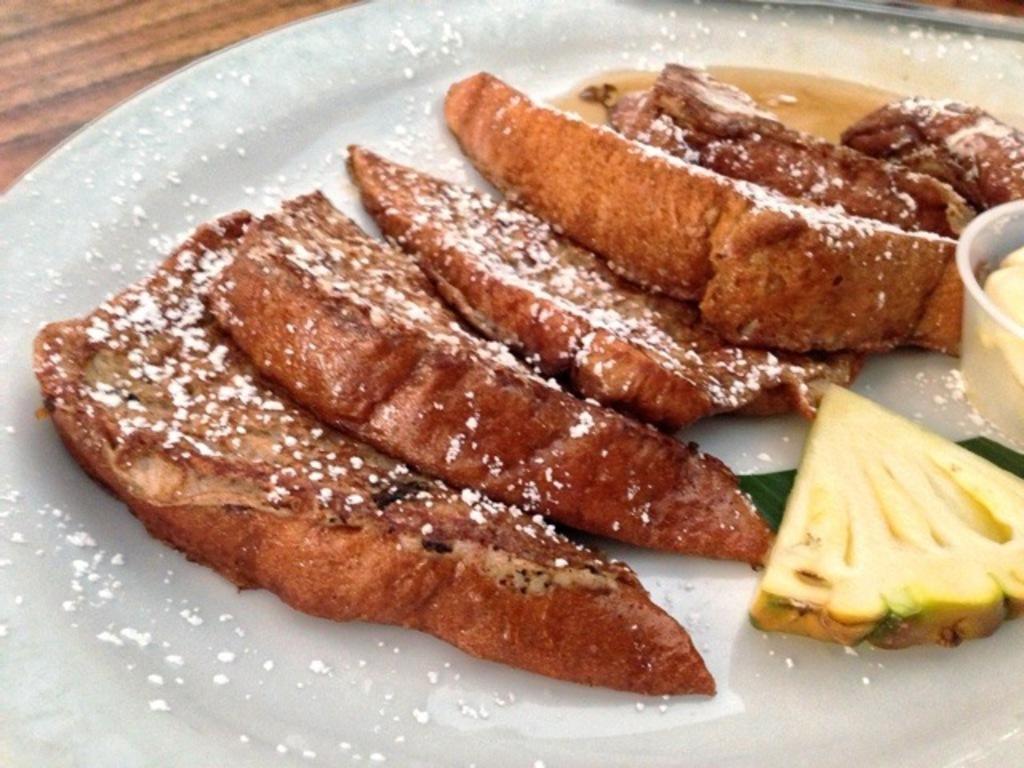How would you summarize this image in a sentence or two? In this image I can see a plate in which food items are there kept on a table. This image is taken may be in a room. 